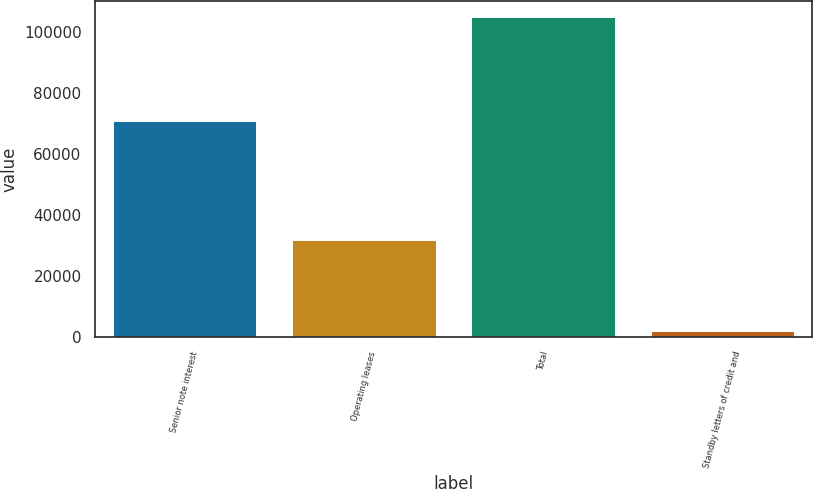<chart> <loc_0><loc_0><loc_500><loc_500><bar_chart><fcel>Senior note interest<fcel>Operating leases<fcel>Total<fcel>Standby letters of credit and<nl><fcel>70675<fcel>31852<fcel>104859<fcel>1950<nl></chart> 